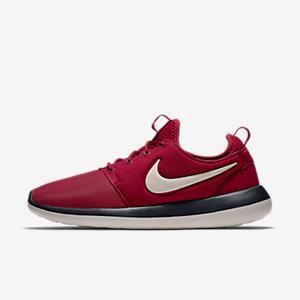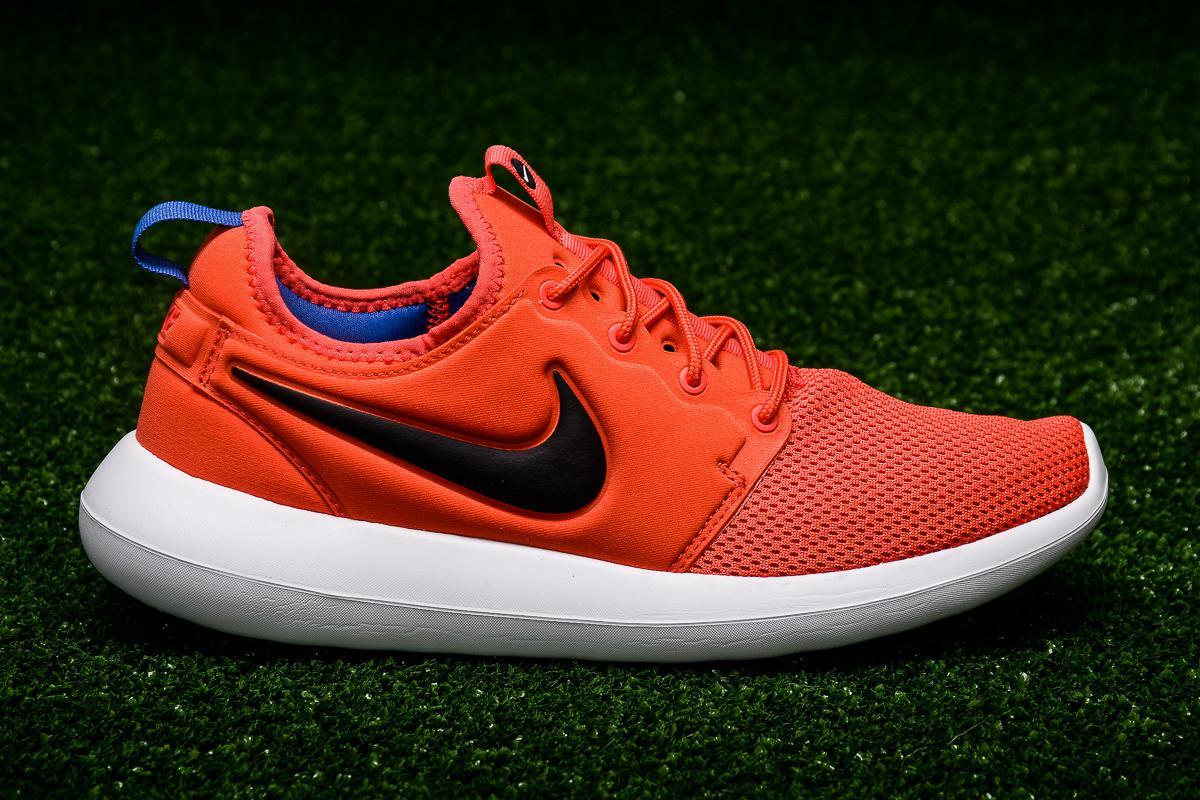The first image is the image on the left, the second image is the image on the right. Evaluate the accuracy of this statement regarding the images: "Left image shows a pair of orange sneakers, and right image shows just one sneaker.". Is it true? Answer yes or no. No. The first image is the image on the left, the second image is the image on the right. Considering the images on both sides, is "The pair of shoes is on the left of the single shoe." valid? Answer yes or no. No. 